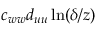Convert formula to latex. <formula><loc_0><loc_0><loc_500><loc_500>c _ { w w } d _ { u u } \ln ( \delta / z )</formula> 